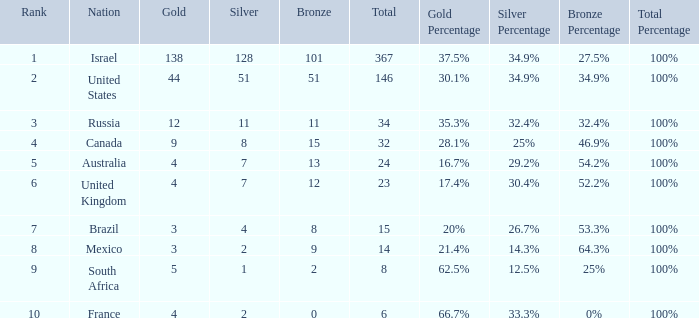What is the maximum number of silvers for a country with fewer than 12 golds and a total less than 8? 2.0. 